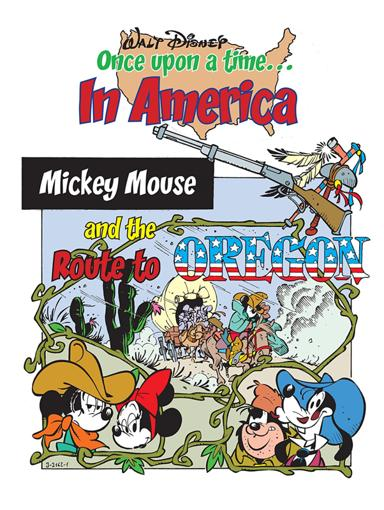What are some popular Disney characters? Some popular Disney characters prominently featured in the image include Mickey Mouse, Minnie Mouse, and Goofy. These characters are integral to both Disney's brand and the thematic storytelling of their adventures, as seen in this image portraying an imaginative journey to Oregon. 